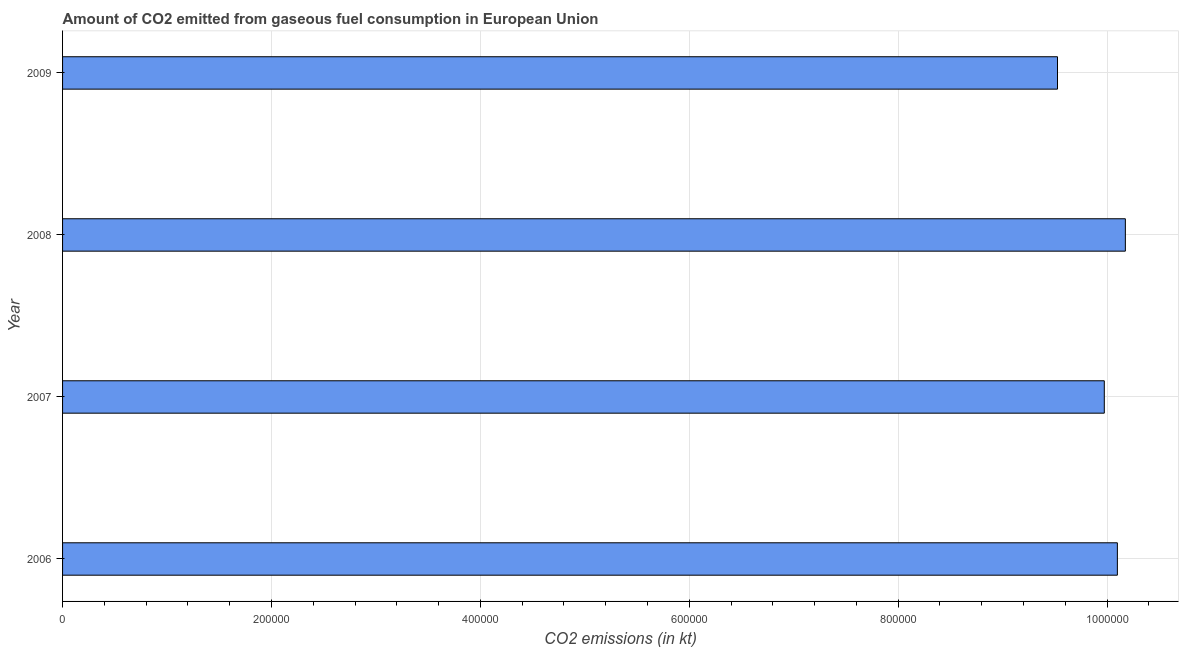Does the graph contain any zero values?
Give a very brief answer. No. What is the title of the graph?
Provide a short and direct response. Amount of CO2 emitted from gaseous fuel consumption in European Union. What is the label or title of the X-axis?
Your answer should be compact. CO2 emissions (in kt). What is the co2 emissions from gaseous fuel consumption in 2007?
Offer a very short reply. 9.97e+05. Across all years, what is the maximum co2 emissions from gaseous fuel consumption?
Your response must be concise. 1.02e+06. Across all years, what is the minimum co2 emissions from gaseous fuel consumption?
Offer a very short reply. 9.53e+05. In which year was the co2 emissions from gaseous fuel consumption maximum?
Offer a very short reply. 2008. What is the sum of the co2 emissions from gaseous fuel consumption?
Make the answer very short. 3.98e+06. What is the difference between the co2 emissions from gaseous fuel consumption in 2006 and 2007?
Make the answer very short. 1.25e+04. What is the average co2 emissions from gaseous fuel consumption per year?
Your response must be concise. 9.94e+05. What is the median co2 emissions from gaseous fuel consumption?
Your response must be concise. 1.00e+06. In how many years, is the co2 emissions from gaseous fuel consumption greater than 1000000 kt?
Provide a short and direct response. 2. What is the ratio of the co2 emissions from gaseous fuel consumption in 2007 to that in 2009?
Ensure brevity in your answer.  1.05. Is the difference between the co2 emissions from gaseous fuel consumption in 2007 and 2008 greater than the difference between any two years?
Offer a terse response. No. What is the difference between the highest and the second highest co2 emissions from gaseous fuel consumption?
Provide a short and direct response. 7632.07. What is the difference between the highest and the lowest co2 emissions from gaseous fuel consumption?
Offer a very short reply. 6.50e+04. In how many years, is the co2 emissions from gaseous fuel consumption greater than the average co2 emissions from gaseous fuel consumption taken over all years?
Give a very brief answer. 3. How many bars are there?
Give a very brief answer. 4. Are all the bars in the graph horizontal?
Your response must be concise. Yes. What is the difference between two consecutive major ticks on the X-axis?
Your answer should be compact. 2.00e+05. What is the CO2 emissions (in kt) of 2006?
Ensure brevity in your answer.  1.01e+06. What is the CO2 emissions (in kt) in 2007?
Give a very brief answer. 9.97e+05. What is the CO2 emissions (in kt) of 2008?
Offer a terse response. 1.02e+06. What is the CO2 emissions (in kt) of 2009?
Offer a very short reply. 9.53e+05. What is the difference between the CO2 emissions (in kt) in 2006 and 2007?
Offer a terse response. 1.25e+04. What is the difference between the CO2 emissions (in kt) in 2006 and 2008?
Offer a very short reply. -7632.07. What is the difference between the CO2 emissions (in kt) in 2006 and 2009?
Make the answer very short. 5.73e+04. What is the difference between the CO2 emissions (in kt) in 2007 and 2008?
Make the answer very short. -2.02e+04. What is the difference between the CO2 emissions (in kt) in 2007 and 2009?
Your answer should be compact. 4.48e+04. What is the difference between the CO2 emissions (in kt) in 2008 and 2009?
Your answer should be very brief. 6.50e+04. What is the ratio of the CO2 emissions (in kt) in 2006 to that in 2008?
Your response must be concise. 0.99. What is the ratio of the CO2 emissions (in kt) in 2006 to that in 2009?
Ensure brevity in your answer.  1.06. What is the ratio of the CO2 emissions (in kt) in 2007 to that in 2008?
Give a very brief answer. 0.98. What is the ratio of the CO2 emissions (in kt) in 2007 to that in 2009?
Provide a succinct answer. 1.05. What is the ratio of the CO2 emissions (in kt) in 2008 to that in 2009?
Your answer should be compact. 1.07. 